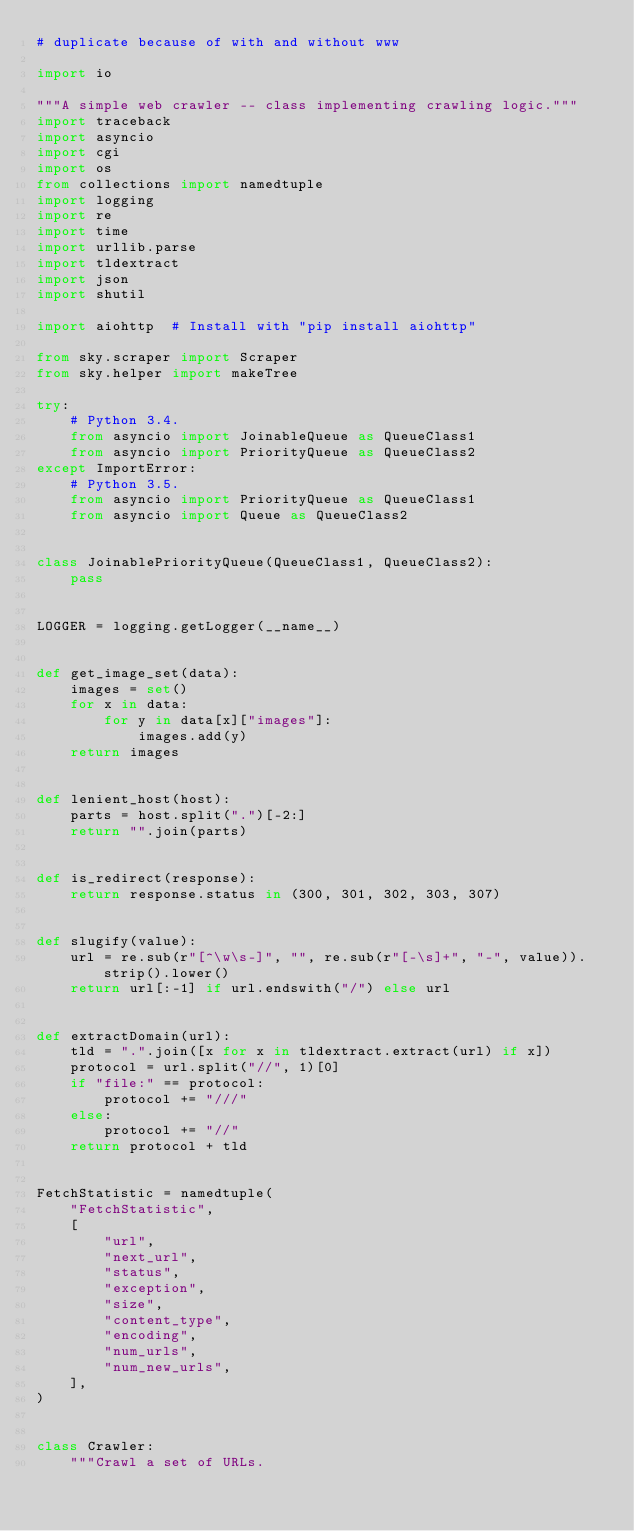<code> <loc_0><loc_0><loc_500><loc_500><_Python_># duplicate because of with and without www

import io

"""A simple web crawler -- class implementing crawling logic."""
import traceback
import asyncio
import cgi
import os
from collections import namedtuple
import logging
import re
import time
import urllib.parse
import tldextract
import json
import shutil

import aiohttp  # Install with "pip install aiohttp"

from sky.scraper import Scraper
from sky.helper import makeTree

try:
    # Python 3.4.
    from asyncio import JoinableQueue as QueueClass1
    from asyncio import PriorityQueue as QueueClass2
except ImportError:
    # Python 3.5.
    from asyncio import PriorityQueue as QueueClass1
    from asyncio import Queue as QueueClass2


class JoinablePriorityQueue(QueueClass1, QueueClass2):
    pass


LOGGER = logging.getLogger(__name__)


def get_image_set(data):
    images = set()
    for x in data:
        for y in data[x]["images"]:
            images.add(y)
    return images


def lenient_host(host):
    parts = host.split(".")[-2:]
    return "".join(parts)


def is_redirect(response):
    return response.status in (300, 301, 302, 303, 307)


def slugify(value):
    url = re.sub(r"[^\w\s-]", "", re.sub(r"[-\s]+", "-", value)).strip().lower()
    return url[:-1] if url.endswith("/") else url


def extractDomain(url):
    tld = ".".join([x for x in tldextract.extract(url) if x])
    protocol = url.split("//", 1)[0]
    if "file:" == protocol:
        protocol += "///"
    else:
        protocol += "//"
    return protocol + tld


FetchStatistic = namedtuple(
    "FetchStatistic",
    [
        "url",
        "next_url",
        "status",
        "exception",
        "size",
        "content_type",
        "encoding",
        "num_urls",
        "num_new_urls",
    ],
)


class Crawler:
    """Crawl a set of URLs.
</code> 